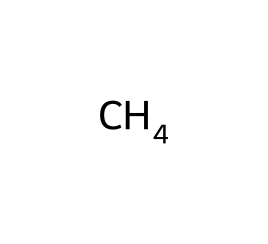What is the molecular formula of methane? Methane is composed of one carbon atom and four hydrogen atoms, which gives it the molecular formula of CH4.
Answer: CH4 How many H atoms are present in methane? The chemical structure of methane indicates that there are four hydrogen atoms attached to the carbon atom.
Answer: 4 Is methane a saturated or unsaturated hydrocarbon? Methane is classified as a saturated hydrocarbon because it contains only single bonds between the carbon and hydrogen atoms.
Answer: saturated What is the bond angle in methane? In methane, the bond angle between the hydrogen atoms is approximately 109.5 degrees, which is characteristic of its tetrahedral geometry.
Answer: 109.5 degrees Why is methane commonly used as a fuel for households? Methane is a highly efficient fuel because it has a high energy content and produces clean combustion with minimal pollutants when burned.
Answer: high energy content How does the arrangement of atoms in methane influence its combustion properties? The tetrahedral arrangement of hydrogen atoms around the carbon in methane allows for efficient bonding and energy release during combustion, resulting in efficient fuel usage.
Answer: efficient bonding 